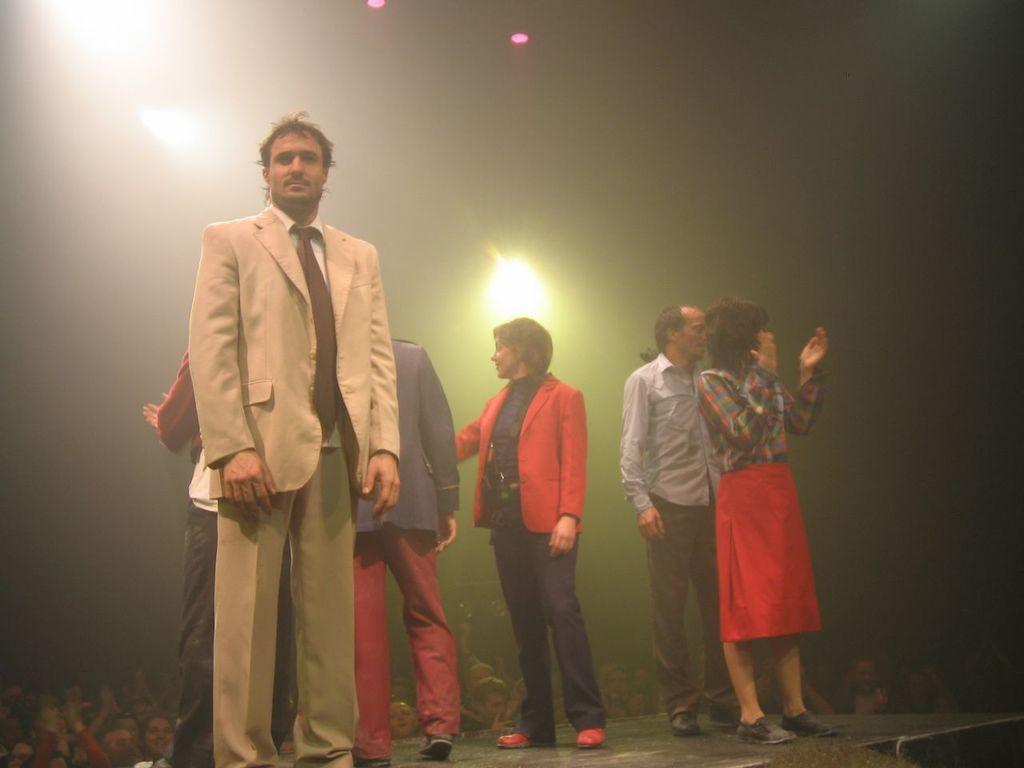What is happening in the image involving a group of people? There is a group of people on a stage in the image. Are there any people not on the stage in the image? Yes, there are people at the bottom of the stage in the image. Can you describe the expressions of the people in the image? Some people are smiling in the image. What can be seen in the background of the image? There are lights visible in the background of the image. What type of cream is being used to tie a knot in the image? There is no cream or knot present in the image. Can you describe the flower arrangement on the stage in the image? There is no flower arrangement mentioned in the provided facts; the image only features a group of people on a stage and people at the bottom of the stage. 